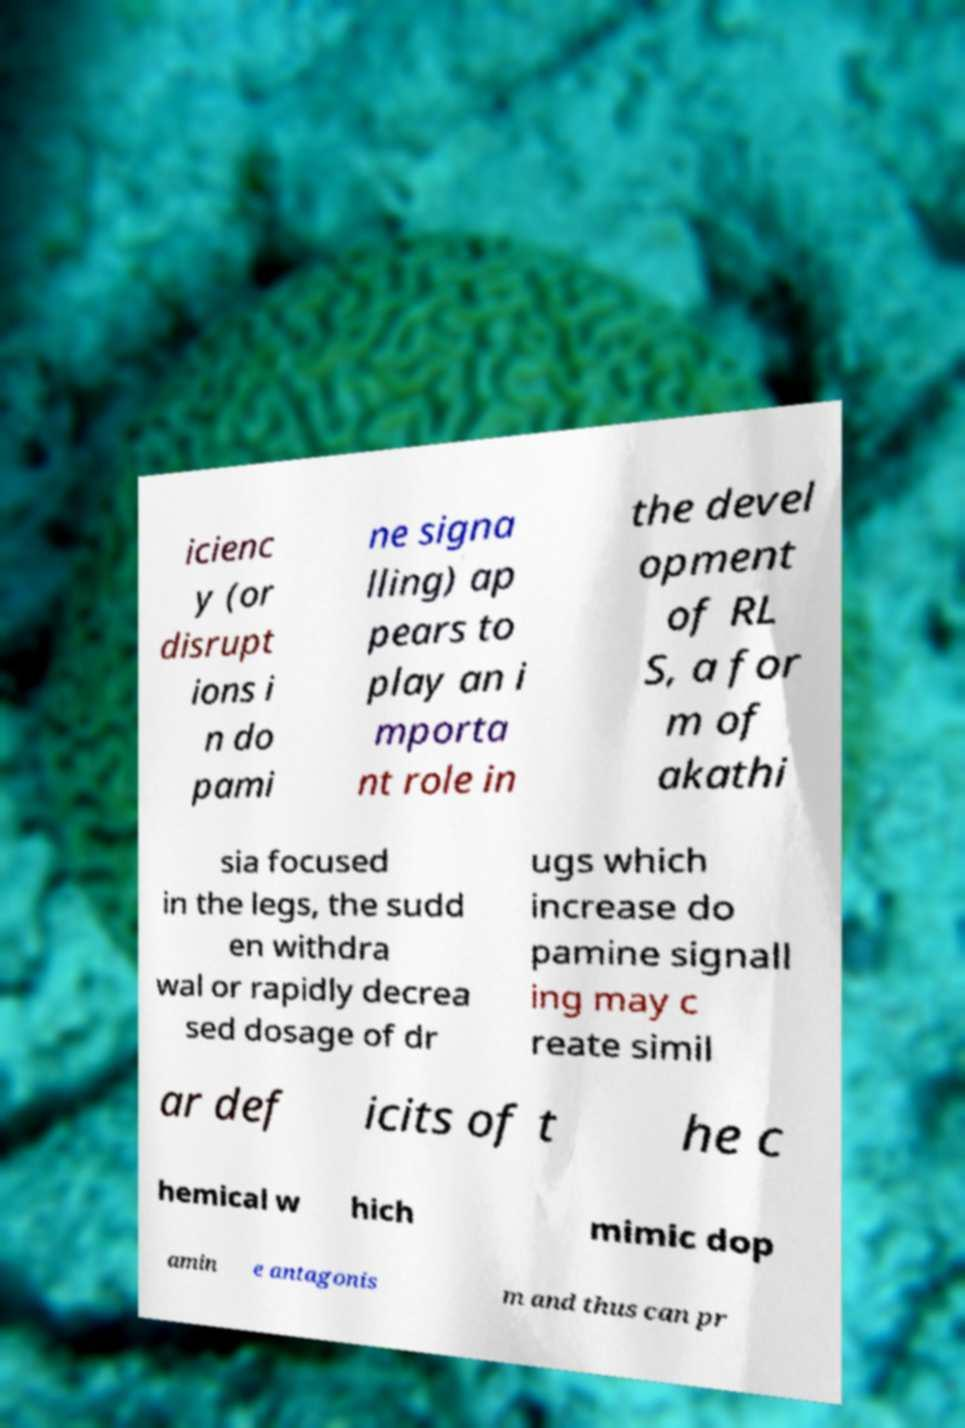Can you accurately transcribe the text from the provided image for me? icienc y (or disrupt ions i n do pami ne signa lling) ap pears to play an i mporta nt role in the devel opment of RL S, a for m of akathi sia focused in the legs, the sudd en withdra wal or rapidly decrea sed dosage of dr ugs which increase do pamine signall ing may c reate simil ar def icits of t he c hemical w hich mimic dop amin e antagonis m and thus can pr 